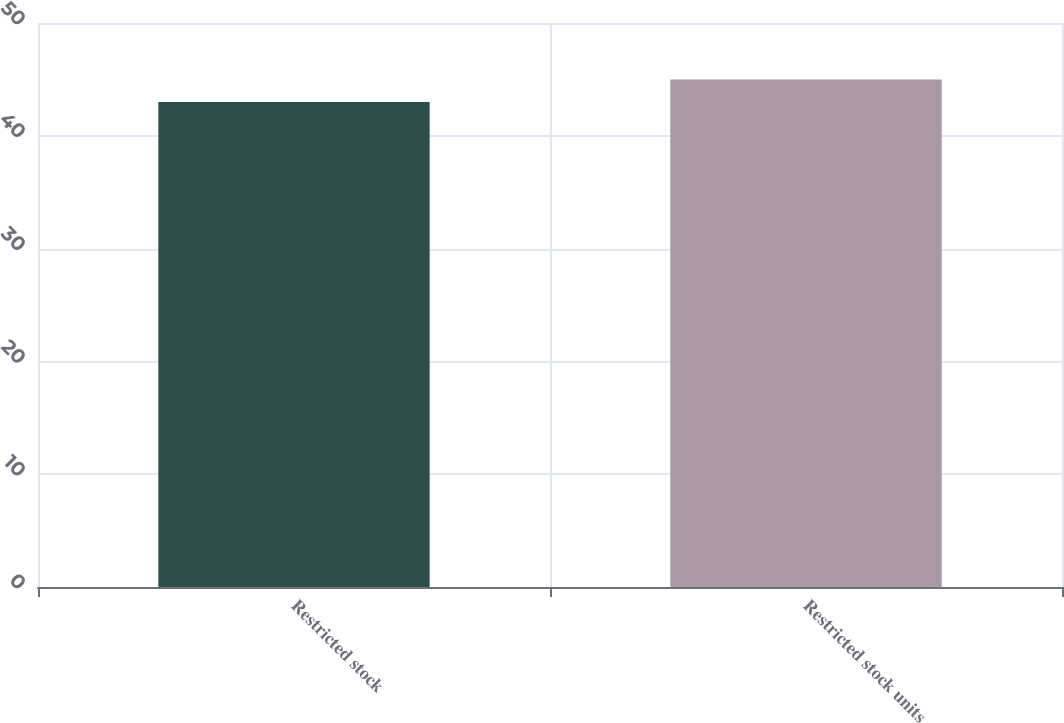Convert chart. <chart><loc_0><loc_0><loc_500><loc_500><bar_chart><fcel>Restricted stock<fcel>Restricted stock units<nl><fcel>43<fcel>45<nl></chart> 